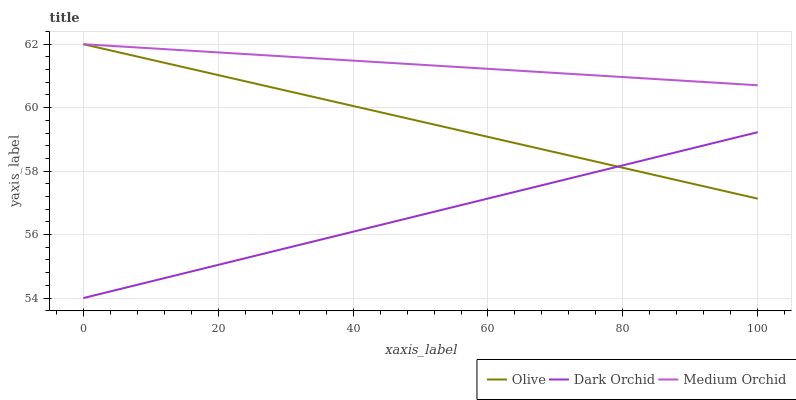Does Dark Orchid have the minimum area under the curve?
Answer yes or no. Yes. Does Medium Orchid have the maximum area under the curve?
Answer yes or no. Yes. Does Medium Orchid have the minimum area under the curve?
Answer yes or no. No. Does Dark Orchid have the maximum area under the curve?
Answer yes or no. No. Is Dark Orchid the smoothest?
Answer yes or no. Yes. Is Olive the roughest?
Answer yes or no. Yes. Is Medium Orchid the smoothest?
Answer yes or no. No. Is Medium Orchid the roughest?
Answer yes or no. No. Does Dark Orchid have the lowest value?
Answer yes or no. Yes. Does Medium Orchid have the lowest value?
Answer yes or no. No. Does Medium Orchid have the highest value?
Answer yes or no. Yes. Does Dark Orchid have the highest value?
Answer yes or no. No. Is Dark Orchid less than Medium Orchid?
Answer yes or no. Yes. Is Medium Orchid greater than Dark Orchid?
Answer yes or no. Yes. Does Olive intersect Dark Orchid?
Answer yes or no. Yes. Is Olive less than Dark Orchid?
Answer yes or no. No. Is Olive greater than Dark Orchid?
Answer yes or no. No. Does Dark Orchid intersect Medium Orchid?
Answer yes or no. No. 